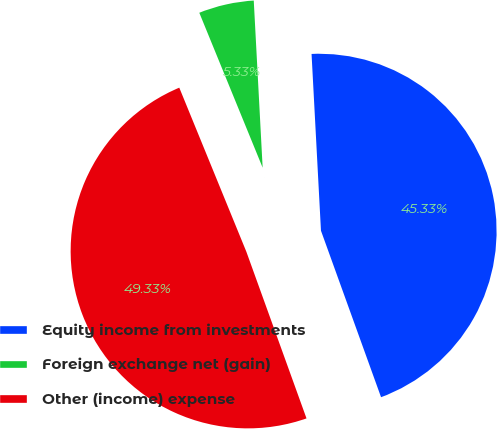Convert chart to OTSL. <chart><loc_0><loc_0><loc_500><loc_500><pie_chart><fcel>Equity income from investments<fcel>Foreign exchange net (gain)<fcel>Other (income) expense<nl><fcel>45.33%<fcel>5.33%<fcel>49.33%<nl></chart> 